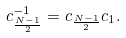<formula> <loc_0><loc_0><loc_500><loc_500>c _ { \frac { N - 1 } { 2 } } ^ { - 1 } = c _ { \frac { N - 1 } { 2 } } c _ { 1 } .</formula> 